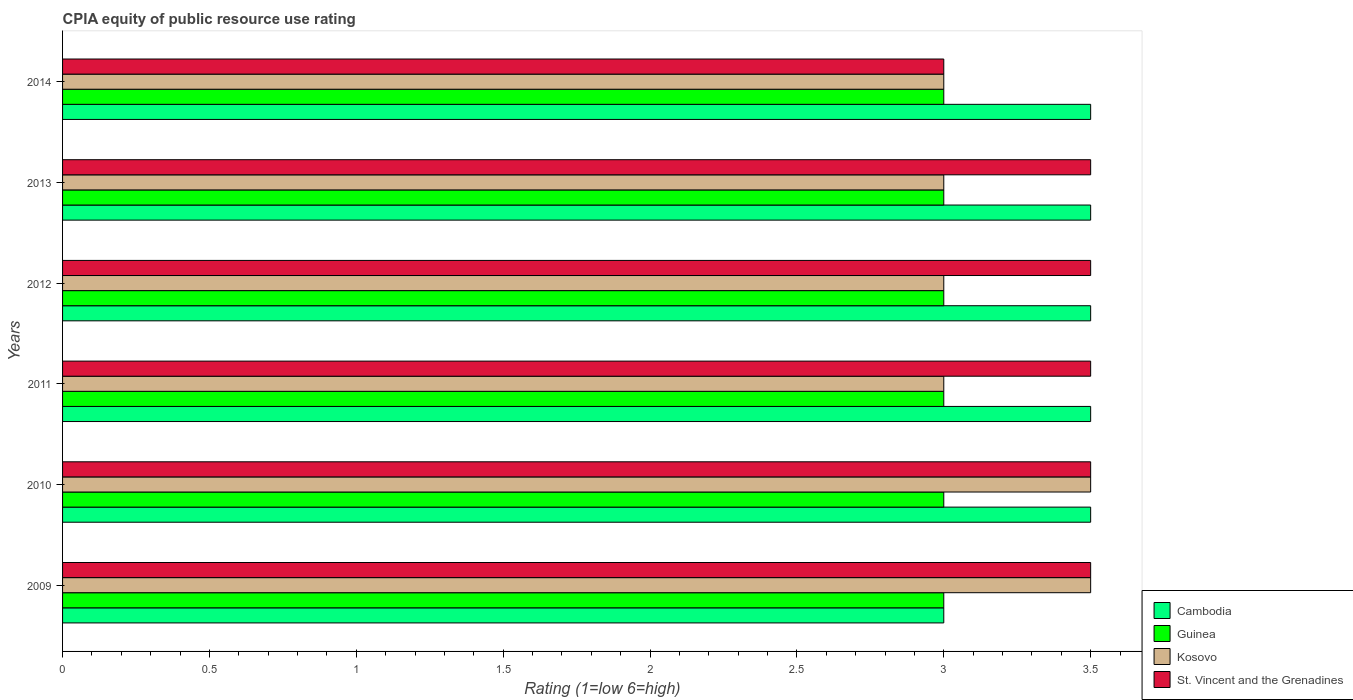Are the number of bars per tick equal to the number of legend labels?
Provide a succinct answer. Yes. Are the number of bars on each tick of the Y-axis equal?
Your response must be concise. Yes. How many bars are there on the 4th tick from the bottom?
Ensure brevity in your answer.  4. In how many cases, is the number of bars for a given year not equal to the number of legend labels?
Make the answer very short. 0. Across all years, what is the maximum CPIA rating in St. Vincent and the Grenadines?
Provide a succinct answer. 3.5. Across all years, what is the minimum CPIA rating in Kosovo?
Your answer should be compact. 3. In which year was the CPIA rating in Kosovo maximum?
Make the answer very short. 2009. What is the total CPIA rating in Cambodia in the graph?
Your answer should be very brief. 20.5. What is the difference between the CPIA rating in St. Vincent and the Grenadines in 2009 and the CPIA rating in Cambodia in 2014?
Ensure brevity in your answer.  0. What is the average CPIA rating in St. Vincent and the Grenadines per year?
Your answer should be compact. 3.42. In the year 2009, what is the difference between the CPIA rating in Cambodia and CPIA rating in Guinea?
Provide a succinct answer. 0. In how many years, is the CPIA rating in St. Vincent and the Grenadines greater than 1.7 ?
Provide a short and direct response. 6. Is the CPIA rating in St. Vincent and the Grenadines in 2010 less than that in 2012?
Ensure brevity in your answer.  No. What is the difference between the highest and the second highest CPIA rating in St. Vincent and the Grenadines?
Offer a terse response. 0. What is the difference between the highest and the lowest CPIA rating in St. Vincent and the Grenadines?
Offer a terse response. 0.5. Is the sum of the CPIA rating in Guinea in 2010 and 2013 greater than the maximum CPIA rating in Kosovo across all years?
Your answer should be compact. Yes. What does the 3rd bar from the top in 2011 represents?
Your answer should be very brief. Guinea. What does the 4th bar from the bottom in 2009 represents?
Your response must be concise. St. Vincent and the Grenadines. Are all the bars in the graph horizontal?
Make the answer very short. Yes. How many years are there in the graph?
Your answer should be very brief. 6. Are the values on the major ticks of X-axis written in scientific E-notation?
Make the answer very short. No. Does the graph contain any zero values?
Give a very brief answer. No. Where does the legend appear in the graph?
Give a very brief answer. Bottom right. How are the legend labels stacked?
Give a very brief answer. Vertical. What is the title of the graph?
Your answer should be compact. CPIA equity of public resource use rating. Does "Senegal" appear as one of the legend labels in the graph?
Ensure brevity in your answer.  No. What is the label or title of the Y-axis?
Offer a very short reply. Years. What is the Rating (1=low 6=high) of Cambodia in 2009?
Your answer should be very brief. 3. What is the Rating (1=low 6=high) in Guinea in 2009?
Your response must be concise. 3. What is the Rating (1=low 6=high) of St. Vincent and the Grenadines in 2009?
Your response must be concise. 3.5. What is the Rating (1=low 6=high) in Cambodia in 2011?
Provide a succinct answer. 3.5. What is the Rating (1=low 6=high) of Guinea in 2011?
Give a very brief answer. 3. What is the Rating (1=low 6=high) in Cambodia in 2012?
Give a very brief answer. 3.5. What is the Rating (1=low 6=high) in Kosovo in 2012?
Offer a terse response. 3. What is the Rating (1=low 6=high) in St. Vincent and the Grenadines in 2012?
Your response must be concise. 3.5. What is the Rating (1=low 6=high) in St. Vincent and the Grenadines in 2013?
Offer a very short reply. 3.5. What is the Rating (1=low 6=high) of Cambodia in 2014?
Your response must be concise. 3.5. What is the Rating (1=low 6=high) in Guinea in 2014?
Your answer should be very brief. 3. Across all years, what is the maximum Rating (1=low 6=high) in Cambodia?
Ensure brevity in your answer.  3.5. Across all years, what is the minimum Rating (1=low 6=high) in Cambodia?
Your response must be concise. 3. Across all years, what is the minimum Rating (1=low 6=high) in Guinea?
Your response must be concise. 3. Across all years, what is the minimum Rating (1=low 6=high) of Kosovo?
Ensure brevity in your answer.  3. What is the total Rating (1=low 6=high) in Kosovo in the graph?
Provide a succinct answer. 19. What is the difference between the Rating (1=low 6=high) of Kosovo in 2009 and that in 2010?
Offer a terse response. 0. What is the difference between the Rating (1=low 6=high) in St. Vincent and the Grenadines in 2009 and that in 2010?
Your answer should be very brief. 0. What is the difference between the Rating (1=low 6=high) of Cambodia in 2009 and that in 2011?
Make the answer very short. -0.5. What is the difference between the Rating (1=low 6=high) of Guinea in 2009 and that in 2011?
Your answer should be compact. 0. What is the difference between the Rating (1=low 6=high) of Kosovo in 2009 and that in 2011?
Offer a terse response. 0.5. What is the difference between the Rating (1=low 6=high) in St. Vincent and the Grenadines in 2009 and that in 2011?
Offer a terse response. 0. What is the difference between the Rating (1=low 6=high) of Cambodia in 2009 and that in 2012?
Your answer should be very brief. -0.5. What is the difference between the Rating (1=low 6=high) in Guinea in 2009 and that in 2012?
Your answer should be very brief. 0. What is the difference between the Rating (1=low 6=high) of Kosovo in 2009 and that in 2012?
Make the answer very short. 0.5. What is the difference between the Rating (1=low 6=high) in St. Vincent and the Grenadines in 2009 and that in 2012?
Ensure brevity in your answer.  0. What is the difference between the Rating (1=low 6=high) of Cambodia in 2009 and that in 2013?
Your answer should be very brief. -0.5. What is the difference between the Rating (1=low 6=high) in Kosovo in 2009 and that in 2013?
Your answer should be very brief. 0.5. What is the difference between the Rating (1=low 6=high) in St. Vincent and the Grenadines in 2009 and that in 2013?
Ensure brevity in your answer.  0. What is the difference between the Rating (1=low 6=high) in Cambodia in 2009 and that in 2014?
Your response must be concise. -0.5. What is the difference between the Rating (1=low 6=high) in Guinea in 2009 and that in 2014?
Keep it short and to the point. 0. What is the difference between the Rating (1=low 6=high) of Cambodia in 2010 and that in 2011?
Offer a terse response. 0. What is the difference between the Rating (1=low 6=high) in St. Vincent and the Grenadines in 2010 and that in 2011?
Keep it short and to the point. 0. What is the difference between the Rating (1=low 6=high) in Cambodia in 2010 and that in 2012?
Offer a very short reply. 0. What is the difference between the Rating (1=low 6=high) of Guinea in 2010 and that in 2012?
Provide a succinct answer. 0. What is the difference between the Rating (1=low 6=high) of Kosovo in 2010 and that in 2012?
Provide a short and direct response. 0.5. What is the difference between the Rating (1=low 6=high) in Guinea in 2010 and that in 2013?
Your answer should be very brief. 0. What is the difference between the Rating (1=low 6=high) of Cambodia in 2010 and that in 2014?
Ensure brevity in your answer.  0. What is the difference between the Rating (1=low 6=high) of Guinea in 2010 and that in 2014?
Offer a very short reply. 0. What is the difference between the Rating (1=low 6=high) of Cambodia in 2011 and that in 2012?
Offer a very short reply. 0. What is the difference between the Rating (1=low 6=high) in Guinea in 2011 and that in 2012?
Offer a very short reply. 0. What is the difference between the Rating (1=low 6=high) in St. Vincent and the Grenadines in 2011 and that in 2012?
Your response must be concise. 0. What is the difference between the Rating (1=low 6=high) of Cambodia in 2011 and that in 2013?
Your answer should be very brief. 0. What is the difference between the Rating (1=low 6=high) of St. Vincent and the Grenadines in 2011 and that in 2013?
Offer a very short reply. 0. What is the difference between the Rating (1=low 6=high) in Guinea in 2011 and that in 2014?
Provide a succinct answer. 0. What is the difference between the Rating (1=low 6=high) in St. Vincent and the Grenadines in 2011 and that in 2014?
Provide a short and direct response. 0.5. What is the difference between the Rating (1=low 6=high) of Cambodia in 2012 and that in 2014?
Make the answer very short. 0. What is the difference between the Rating (1=low 6=high) of Guinea in 2012 and that in 2014?
Provide a short and direct response. 0. What is the difference between the Rating (1=low 6=high) in St. Vincent and the Grenadines in 2012 and that in 2014?
Ensure brevity in your answer.  0.5. What is the difference between the Rating (1=low 6=high) in Guinea in 2013 and that in 2014?
Your answer should be very brief. 0. What is the difference between the Rating (1=low 6=high) in St. Vincent and the Grenadines in 2013 and that in 2014?
Ensure brevity in your answer.  0.5. What is the difference between the Rating (1=low 6=high) in Cambodia in 2009 and the Rating (1=low 6=high) in Guinea in 2010?
Your answer should be compact. 0. What is the difference between the Rating (1=low 6=high) in Cambodia in 2009 and the Rating (1=low 6=high) in Kosovo in 2010?
Make the answer very short. -0.5. What is the difference between the Rating (1=low 6=high) of Guinea in 2009 and the Rating (1=low 6=high) of Kosovo in 2010?
Your response must be concise. -0.5. What is the difference between the Rating (1=low 6=high) in Guinea in 2009 and the Rating (1=low 6=high) in St. Vincent and the Grenadines in 2010?
Make the answer very short. -0.5. What is the difference between the Rating (1=low 6=high) in Cambodia in 2009 and the Rating (1=low 6=high) in Guinea in 2011?
Keep it short and to the point. 0. What is the difference between the Rating (1=low 6=high) in Cambodia in 2009 and the Rating (1=low 6=high) in Kosovo in 2011?
Your answer should be very brief. 0. What is the difference between the Rating (1=low 6=high) in Cambodia in 2009 and the Rating (1=low 6=high) in St. Vincent and the Grenadines in 2011?
Your answer should be very brief. -0.5. What is the difference between the Rating (1=low 6=high) of Kosovo in 2009 and the Rating (1=low 6=high) of St. Vincent and the Grenadines in 2011?
Your response must be concise. 0. What is the difference between the Rating (1=low 6=high) in Cambodia in 2009 and the Rating (1=low 6=high) in Kosovo in 2012?
Offer a terse response. 0. What is the difference between the Rating (1=low 6=high) in Guinea in 2009 and the Rating (1=low 6=high) in St. Vincent and the Grenadines in 2012?
Your answer should be very brief. -0.5. What is the difference between the Rating (1=low 6=high) in Guinea in 2009 and the Rating (1=low 6=high) in Kosovo in 2013?
Provide a succinct answer. 0. What is the difference between the Rating (1=low 6=high) of Guinea in 2009 and the Rating (1=low 6=high) of St. Vincent and the Grenadines in 2013?
Your answer should be compact. -0.5. What is the difference between the Rating (1=low 6=high) of Kosovo in 2009 and the Rating (1=low 6=high) of St. Vincent and the Grenadines in 2013?
Provide a succinct answer. 0. What is the difference between the Rating (1=low 6=high) in Cambodia in 2009 and the Rating (1=low 6=high) in Kosovo in 2014?
Your answer should be compact. 0. What is the difference between the Rating (1=low 6=high) in Cambodia in 2009 and the Rating (1=low 6=high) in St. Vincent and the Grenadines in 2014?
Ensure brevity in your answer.  0. What is the difference between the Rating (1=low 6=high) in Guinea in 2009 and the Rating (1=low 6=high) in Kosovo in 2014?
Make the answer very short. 0. What is the difference between the Rating (1=low 6=high) of Guinea in 2009 and the Rating (1=low 6=high) of St. Vincent and the Grenadines in 2014?
Offer a very short reply. 0. What is the difference between the Rating (1=low 6=high) of Kosovo in 2009 and the Rating (1=low 6=high) of St. Vincent and the Grenadines in 2014?
Offer a terse response. 0.5. What is the difference between the Rating (1=low 6=high) in Cambodia in 2010 and the Rating (1=low 6=high) in Guinea in 2011?
Give a very brief answer. 0.5. What is the difference between the Rating (1=low 6=high) in Cambodia in 2010 and the Rating (1=low 6=high) in St. Vincent and the Grenadines in 2011?
Offer a very short reply. 0. What is the difference between the Rating (1=low 6=high) of Guinea in 2010 and the Rating (1=low 6=high) of Kosovo in 2011?
Provide a short and direct response. 0. What is the difference between the Rating (1=low 6=high) in Guinea in 2010 and the Rating (1=low 6=high) in St. Vincent and the Grenadines in 2011?
Your answer should be compact. -0.5. What is the difference between the Rating (1=low 6=high) in Cambodia in 2010 and the Rating (1=low 6=high) in Guinea in 2012?
Offer a very short reply. 0.5. What is the difference between the Rating (1=low 6=high) of Kosovo in 2010 and the Rating (1=low 6=high) of St. Vincent and the Grenadines in 2012?
Provide a short and direct response. 0. What is the difference between the Rating (1=low 6=high) in Cambodia in 2010 and the Rating (1=low 6=high) in Guinea in 2013?
Offer a terse response. 0.5. What is the difference between the Rating (1=low 6=high) of Cambodia in 2010 and the Rating (1=low 6=high) of St. Vincent and the Grenadines in 2013?
Offer a terse response. 0. What is the difference between the Rating (1=low 6=high) of Guinea in 2010 and the Rating (1=low 6=high) of Kosovo in 2013?
Your answer should be very brief. 0. What is the difference between the Rating (1=low 6=high) of Kosovo in 2010 and the Rating (1=low 6=high) of St. Vincent and the Grenadines in 2013?
Give a very brief answer. 0. What is the difference between the Rating (1=low 6=high) in Cambodia in 2010 and the Rating (1=low 6=high) in Guinea in 2014?
Keep it short and to the point. 0.5. What is the difference between the Rating (1=low 6=high) in Cambodia in 2010 and the Rating (1=low 6=high) in Kosovo in 2014?
Your response must be concise. 0.5. What is the difference between the Rating (1=low 6=high) in Cambodia in 2010 and the Rating (1=low 6=high) in St. Vincent and the Grenadines in 2014?
Provide a short and direct response. 0.5. What is the difference between the Rating (1=low 6=high) of Kosovo in 2011 and the Rating (1=low 6=high) of St. Vincent and the Grenadines in 2012?
Provide a short and direct response. -0.5. What is the difference between the Rating (1=low 6=high) in Guinea in 2011 and the Rating (1=low 6=high) in Kosovo in 2013?
Offer a very short reply. 0. What is the difference between the Rating (1=low 6=high) in Guinea in 2011 and the Rating (1=low 6=high) in St. Vincent and the Grenadines in 2013?
Give a very brief answer. -0.5. What is the difference between the Rating (1=low 6=high) of Cambodia in 2011 and the Rating (1=low 6=high) of Kosovo in 2014?
Your answer should be very brief. 0.5. What is the difference between the Rating (1=low 6=high) in Guinea in 2011 and the Rating (1=low 6=high) in Kosovo in 2014?
Make the answer very short. 0. What is the difference between the Rating (1=low 6=high) in Cambodia in 2012 and the Rating (1=low 6=high) in Guinea in 2013?
Make the answer very short. 0.5. What is the difference between the Rating (1=low 6=high) in Cambodia in 2012 and the Rating (1=low 6=high) in Kosovo in 2013?
Your answer should be very brief. 0.5. What is the difference between the Rating (1=low 6=high) of Guinea in 2012 and the Rating (1=low 6=high) of Kosovo in 2013?
Your answer should be very brief. 0. What is the difference between the Rating (1=low 6=high) in Guinea in 2012 and the Rating (1=low 6=high) in St. Vincent and the Grenadines in 2013?
Your answer should be compact. -0.5. What is the difference between the Rating (1=low 6=high) in Kosovo in 2012 and the Rating (1=low 6=high) in St. Vincent and the Grenadines in 2013?
Your response must be concise. -0.5. What is the difference between the Rating (1=low 6=high) of Cambodia in 2012 and the Rating (1=low 6=high) of Kosovo in 2014?
Keep it short and to the point. 0.5. What is the difference between the Rating (1=low 6=high) in Cambodia in 2012 and the Rating (1=low 6=high) in St. Vincent and the Grenadines in 2014?
Provide a succinct answer. 0.5. What is the difference between the Rating (1=low 6=high) in Guinea in 2012 and the Rating (1=low 6=high) in Kosovo in 2014?
Give a very brief answer. 0. What is the difference between the Rating (1=low 6=high) in Guinea in 2012 and the Rating (1=low 6=high) in St. Vincent and the Grenadines in 2014?
Make the answer very short. 0. What is the average Rating (1=low 6=high) in Cambodia per year?
Make the answer very short. 3.42. What is the average Rating (1=low 6=high) in Guinea per year?
Your response must be concise. 3. What is the average Rating (1=low 6=high) in Kosovo per year?
Provide a short and direct response. 3.17. What is the average Rating (1=low 6=high) in St. Vincent and the Grenadines per year?
Your answer should be compact. 3.42. In the year 2009, what is the difference between the Rating (1=low 6=high) of Cambodia and Rating (1=low 6=high) of Guinea?
Offer a terse response. 0. In the year 2009, what is the difference between the Rating (1=low 6=high) in Cambodia and Rating (1=low 6=high) in Kosovo?
Your answer should be compact. -0.5. In the year 2009, what is the difference between the Rating (1=low 6=high) of Cambodia and Rating (1=low 6=high) of St. Vincent and the Grenadines?
Give a very brief answer. -0.5. In the year 2009, what is the difference between the Rating (1=low 6=high) of Guinea and Rating (1=low 6=high) of St. Vincent and the Grenadines?
Give a very brief answer. -0.5. In the year 2009, what is the difference between the Rating (1=low 6=high) in Kosovo and Rating (1=low 6=high) in St. Vincent and the Grenadines?
Your answer should be very brief. 0. In the year 2010, what is the difference between the Rating (1=low 6=high) of Cambodia and Rating (1=low 6=high) of Guinea?
Provide a short and direct response. 0.5. In the year 2010, what is the difference between the Rating (1=low 6=high) in Cambodia and Rating (1=low 6=high) in St. Vincent and the Grenadines?
Your response must be concise. 0. In the year 2010, what is the difference between the Rating (1=low 6=high) of Guinea and Rating (1=low 6=high) of Kosovo?
Ensure brevity in your answer.  -0.5. In the year 2010, what is the difference between the Rating (1=low 6=high) of Guinea and Rating (1=low 6=high) of St. Vincent and the Grenadines?
Your response must be concise. -0.5. In the year 2011, what is the difference between the Rating (1=low 6=high) in Cambodia and Rating (1=low 6=high) in St. Vincent and the Grenadines?
Make the answer very short. 0. In the year 2011, what is the difference between the Rating (1=low 6=high) in Guinea and Rating (1=low 6=high) in Kosovo?
Give a very brief answer. 0. In the year 2011, what is the difference between the Rating (1=low 6=high) of Kosovo and Rating (1=low 6=high) of St. Vincent and the Grenadines?
Offer a terse response. -0.5. In the year 2012, what is the difference between the Rating (1=low 6=high) of Cambodia and Rating (1=low 6=high) of Kosovo?
Keep it short and to the point. 0.5. In the year 2012, what is the difference between the Rating (1=low 6=high) of Cambodia and Rating (1=low 6=high) of St. Vincent and the Grenadines?
Provide a short and direct response. 0. In the year 2012, what is the difference between the Rating (1=low 6=high) of Guinea and Rating (1=low 6=high) of Kosovo?
Provide a succinct answer. 0. In the year 2013, what is the difference between the Rating (1=low 6=high) in Guinea and Rating (1=low 6=high) in St. Vincent and the Grenadines?
Provide a short and direct response. -0.5. In the year 2013, what is the difference between the Rating (1=low 6=high) of Kosovo and Rating (1=low 6=high) of St. Vincent and the Grenadines?
Offer a very short reply. -0.5. In the year 2014, what is the difference between the Rating (1=low 6=high) of Cambodia and Rating (1=low 6=high) of Kosovo?
Make the answer very short. 0.5. In the year 2014, what is the difference between the Rating (1=low 6=high) of Guinea and Rating (1=low 6=high) of Kosovo?
Ensure brevity in your answer.  0. In the year 2014, what is the difference between the Rating (1=low 6=high) in Guinea and Rating (1=low 6=high) in St. Vincent and the Grenadines?
Offer a terse response. 0. What is the ratio of the Rating (1=low 6=high) of Cambodia in 2009 to that in 2010?
Ensure brevity in your answer.  0.86. What is the ratio of the Rating (1=low 6=high) of Guinea in 2009 to that in 2010?
Make the answer very short. 1. What is the ratio of the Rating (1=low 6=high) of Kosovo in 2009 to that in 2010?
Keep it short and to the point. 1. What is the ratio of the Rating (1=low 6=high) of St. Vincent and the Grenadines in 2009 to that in 2011?
Your answer should be compact. 1. What is the ratio of the Rating (1=low 6=high) of Cambodia in 2009 to that in 2012?
Your response must be concise. 0.86. What is the ratio of the Rating (1=low 6=high) in St. Vincent and the Grenadines in 2009 to that in 2012?
Provide a succinct answer. 1. What is the ratio of the Rating (1=low 6=high) in Kosovo in 2009 to that in 2013?
Ensure brevity in your answer.  1.17. What is the ratio of the Rating (1=low 6=high) in St. Vincent and the Grenadines in 2009 to that in 2013?
Your response must be concise. 1. What is the ratio of the Rating (1=low 6=high) in Guinea in 2009 to that in 2014?
Your response must be concise. 1. What is the ratio of the Rating (1=low 6=high) in St. Vincent and the Grenadines in 2009 to that in 2014?
Offer a terse response. 1.17. What is the ratio of the Rating (1=low 6=high) of Guinea in 2010 to that in 2011?
Offer a very short reply. 1. What is the ratio of the Rating (1=low 6=high) in Cambodia in 2010 to that in 2014?
Provide a succinct answer. 1. What is the ratio of the Rating (1=low 6=high) in Guinea in 2010 to that in 2014?
Offer a terse response. 1. What is the ratio of the Rating (1=low 6=high) of Kosovo in 2010 to that in 2014?
Provide a short and direct response. 1.17. What is the ratio of the Rating (1=low 6=high) of Cambodia in 2011 to that in 2012?
Provide a succinct answer. 1. What is the ratio of the Rating (1=low 6=high) of St. Vincent and the Grenadines in 2011 to that in 2012?
Your response must be concise. 1. What is the ratio of the Rating (1=low 6=high) in Cambodia in 2011 to that in 2013?
Ensure brevity in your answer.  1. What is the ratio of the Rating (1=low 6=high) of Kosovo in 2011 to that in 2014?
Provide a succinct answer. 1. What is the ratio of the Rating (1=low 6=high) in St. Vincent and the Grenadines in 2011 to that in 2014?
Make the answer very short. 1.17. What is the ratio of the Rating (1=low 6=high) in Cambodia in 2012 to that in 2013?
Make the answer very short. 1. What is the ratio of the Rating (1=low 6=high) in Kosovo in 2012 to that in 2013?
Your answer should be compact. 1. What is the ratio of the Rating (1=low 6=high) of St. Vincent and the Grenadines in 2012 to that in 2013?
Offer a very short reply. 1. What is the ratio of the Rating (1=low 6=high) of Guinea in 2012 to that in 2014?
Provide a succinct answer. 1. What is the ratio of the Rating (1=low 6=high) of Kosovo in 2012 to that in 2014?
Your response must be concise. 1. What is the ratio of the Rating (1=low 6=high) in St. Vincent and the Grenadines in 2012 to that in 2014?
Offer a very short reply. 1.17. What is the ratio of the Rating (1=low 6=high) in St. Vincent and the Grenadines in 2013 to that in 2014?
Provide a succinct answer. 1.17. What is the difference between the highest and the second highest Rating (1=low 6=high) of Cambodia?
Give a very brief answer. 0. What is the difference between the highest and the second highest Rating (1=low 6=high) in Guinea?
Offer a terse response. 0. What is the difference between the highest and the lowest Rating (1=low 6=high) in Cambodia?
Your answer should be compact. 0.5. What is the difference between the highest and the lowest Rating (1=low 6=high) of Guinea?
Offer a terse response. 0. What is the difference between the highest and the lowest Rating (1=low 6=high) in St. Vincent and the Grenadines?
Ensure brevity in your answer.  0.5. 